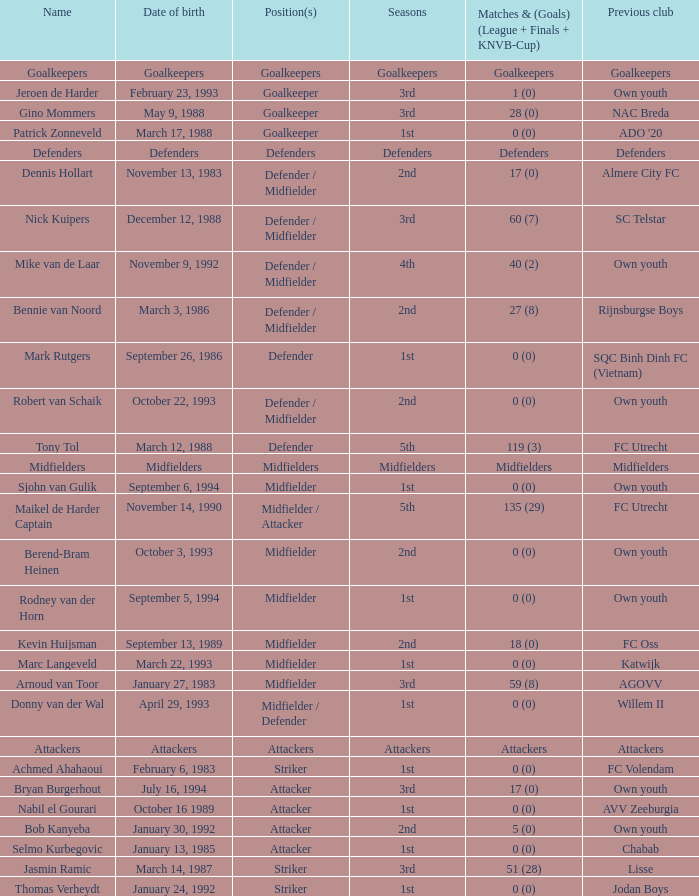What is the date of birth of the goalkeeper from the 1st season? March 17, 1988. Could you parse the entire table? {'header': ['Name', 'Date of birth', 'Position(s)', 'Seasons', 'Matches & (Goals) (League + Finals + KNVB-Cup)', 'Previous club'], 'rows': [['Goalkeepers', 'Goalkeepers', 'Goalkeepers', 'Goalkeepers', 'Goalkeepers', 'Goalkeepers'], ['Jeroen de Harder', 'February 23, 1993', 'Goalkeeper', '3rd', '1 (0)', 'Own youth'], ['Gino Mommers', 'May 9, 1988', 'Goalkeeper', '3rd', '28 (0)', 'NAC Breda'], ['Patrick Zonneveld', 'March 17, 1988', 'Goalkeeper', '1st', '0 (0)', "ADO '20"], ['Defenders', 'Defenders', 'Defenders', 'Defenders', 'Defenders', 'Defenders'], ['Dennis Hollart', 'November 13, 1983', 'Defender / Midfielder', '2nd', '17 (0)', 'Almere City FC'], ['Nick Kuipers', 'December 12, 1988', 'Defender / Midfielder', '3rd', '60 (7)', 'SC Telstar'], ['Mike van de Laar', 'November 9, 1992', 'Defender / Midfielder', '4th', '40 (2)', 'Own youth'], ['Bennie van Noord', 'March 3, 1986', 'Defender / Midfielder', '2nd', '27 (8)', 'Rijnsburgse Boys'], ['Mark Rutgers', 'September 26, 1986', 'Defender', '1st', '0 (0)', 'SQC Binh Dinh FC (Vietnam)'], ['Robert van Schaik', 'October 22, 1993', 'Defender / Midfielder', '2nd', '0 (0)', 'Own youth'], ['Tony Tol', 'March 12, 1988', 'Defender', '5th', '119 (3)', 'FC Utrecht'], ['Midfielders', 'Midfielders', 'Midfielders', 'Midfielders', 'Midfielders', 'Midfielders'], ['Sjohn van Gulik', 'September 6, 1994', 'Midfielder', '1st', '0 (0)', 'Own youth'], ['Maikel de Harder Captain', 'November 14, 1990', 'Midfielder / Attacker', '5th', '135 (29)', 'FC Utrecht'], ['Berend-Bram Heinen', 'October 3, 1993', 'Midfielder', '2nd', '0 (0)', 'Own youth'], ['Rodney van der Horn', 'September 5, 1994', 'Midfielder', '1st', '0 (0)', 'Own youth'], ['Kevin Huijsman', 'September 13, 1989', 'Midfielder', '2nd', '18 (0)', 'FC Oss'], ['Marc Langeveld', 'March 22, 1993', 'Midfielder', '1st', '0 (0)', 'Katwijk'], ['Arnoud van Toor', 'January 27, 1983', 'Midfielder', '3rd', '59 (8)', 'AGOVV'], ['Donny van der Wal', 'April 29, 1993', 'Midfielder / Defender', '1st', '0 (0)', 'Willem II'], ['Attackers', 'Attackers', 'Attackers', 'Attackers', 'Attackers', 'Attackers'], ['Achmed Ahahaoui', 'February 6, 1983', 'Striker', '1st', '0 (0)', 'FC Volendam'], ['Bryan Burgerhout', 'July 16, 1994', 'Attacker', '3rd', '17 (0)', 'Own youth'], ['Nabil el Gourari', 'October 16 1989', 'Attacker', '1st', '0 (0)', 'AVV Zeeburgia'], ['Bob Kanyeba', 'January 30, 1992', 'Attacker', '2nd', '5 (0)', 'Own youth'], ['Selmo Kurbegovic', 'January 13, 1985', 'Attacker', '1st', '0 (0)', 'Chabab'], ['Jasmin Ramic', 'March 14, 1987', 'Striker', '3rd', '51 (28)', 'Lisse'], ['Thomas Verheydt', 'January 24, 1992', 'Striker', '1st', '0 (0)', 'Jodan Boys']]} 